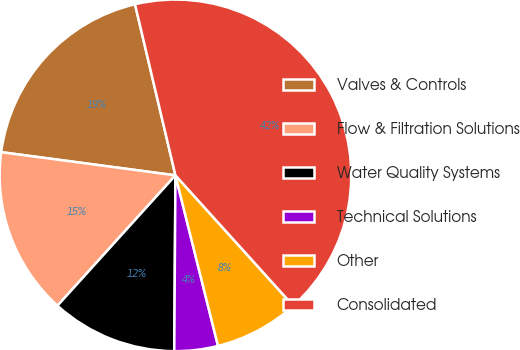<chart> <loc_0><loc_0><loc_500><loc_500><pie_chart><fcel>Valves & Controls<fcel>Flow & Filtration Solutions<fcel>Water Quality Systems<fcel>Technical Solutions<fcel>Other<fcel>Consolidated<nl><fcel>19.2%<fcel>15.4%<fcel>11.6%<fcel>4.0%<fcel>7.8%<fcel>42.0%<nl></chart> 